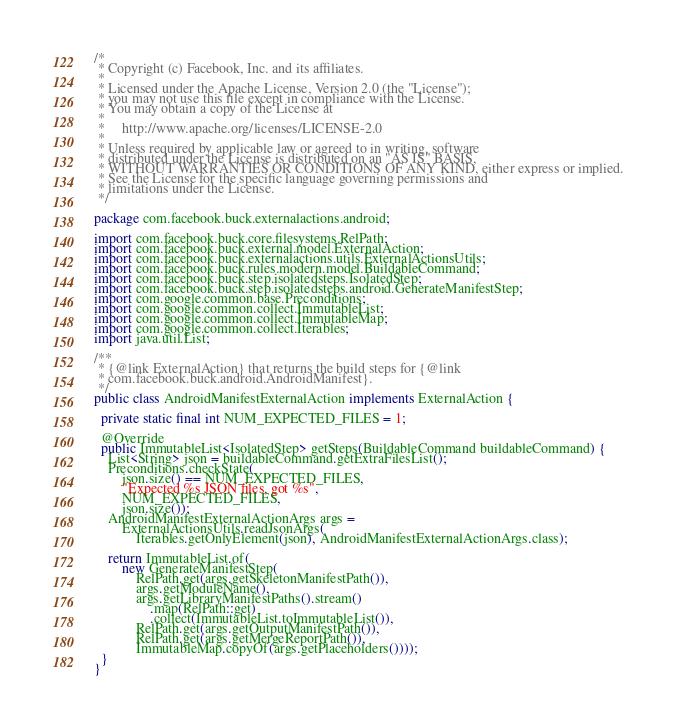Convert code to text. <code><loc_0><loc_0><loc_500><loc_500><_Java_>/*
 * Copyright (c) Facebook, Inc. and its affiliates.
 *
 * Licensed under the Apache License, Version 2.0 (the "License");
 * you may not use this file except in compliance with the License.
 * You may obtain a copy of the License at
 *
 *     http://www.apache.org/licenses/LICENSE-2.0
 *
 * Unless required by applicable law or agreed to in writing, software
 * distributed under the License is distributed on an "AS IS" BASIS,
 * WITHOUT WARRANTIES OR CONDITIONS OF ANY KIND, either express or implied.
 * See the License for the specific language governing permissions and
 * limitations under the License.
 */

package com.facebook.buck.externalactions.android;

import com.facebook.buck.core.filesystems.RelPath;
import com.facebook.buck.external.model.ExternalAction;
import com.facebook.buck.externalactions.utils.ExternalActionsUtils;
import com.facebook.buck.rules.modern.model.BuildableCommand;
import com.facebook.buck.step.isolatedsteps.IsolatedStep;
import com.facebook.buck.step.isolatedsteps.android.GenerateManifestStep;
import com.google.common.base.Preconditions;
import com.google.common.collect.ImmutableList;
import com.google.common.collect.ImmutableMap;
import com.google.common.collect.Iterables;
import java.util.List;

/**
 * {@link ExternalAction} that returns the build steps for {@link
 * com.facebook.buck.android.AndroidManifest}.
 */
public class AndroidManifestExternalAction implements ExternalAction {

  private static final int NUM_EXPECTED_FILES = 1;

  @Override
  public ImmutableList<IsolatedStep> getSteps(BuildableCommand buildableCommand) {
    List<String> json = buildableCommand.getExtraFilesList();
    Preconditions.checkState(
        json.size() == NUM_EXPECTED_FILES,
        "Expected %s JSON files, got %s",
        NUM_EXPECTED_FILES,
        json.size());
    AndroidManifestExternalActionArgs args =
        ExternalActionsUtils.readJsonArgs(
            Iterables.getOnlyElement(json), AndroidManifestExternalActionArgs.class);

    return ImmutableList.of(
        new GenerateManifestStep(
            RelPath.get(args.getSkeletonManifestPath()),
            args.getModuleName(),
            args.getLibraryManifestPaths().stream()
                .map(RelPath::get)
                .collect(ImmutableList.toImmutableList()),
            RelPath.get(args.getOutputManifestPath()),
            RelPath.get(args.getMergeReportPath()),
            ImmutableMap.copyOf(args.getPlaceholders())));
  }
}
</code> 